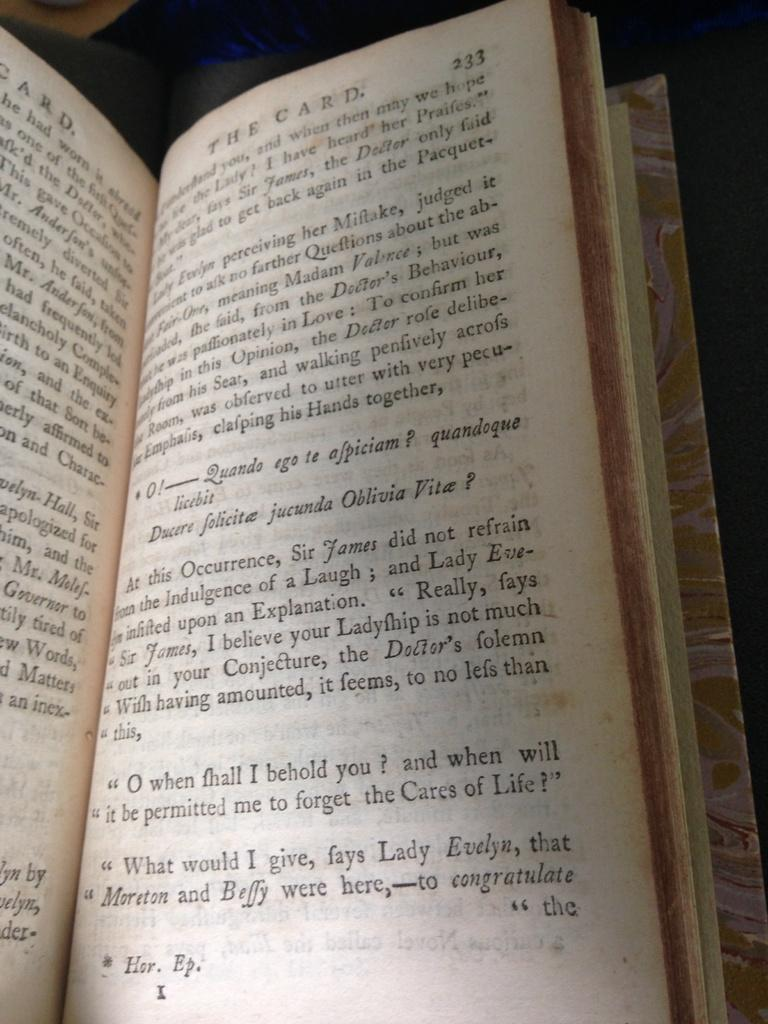<image>
Share a concise interpretation of the image provided. Open book for The Card on page 1. 